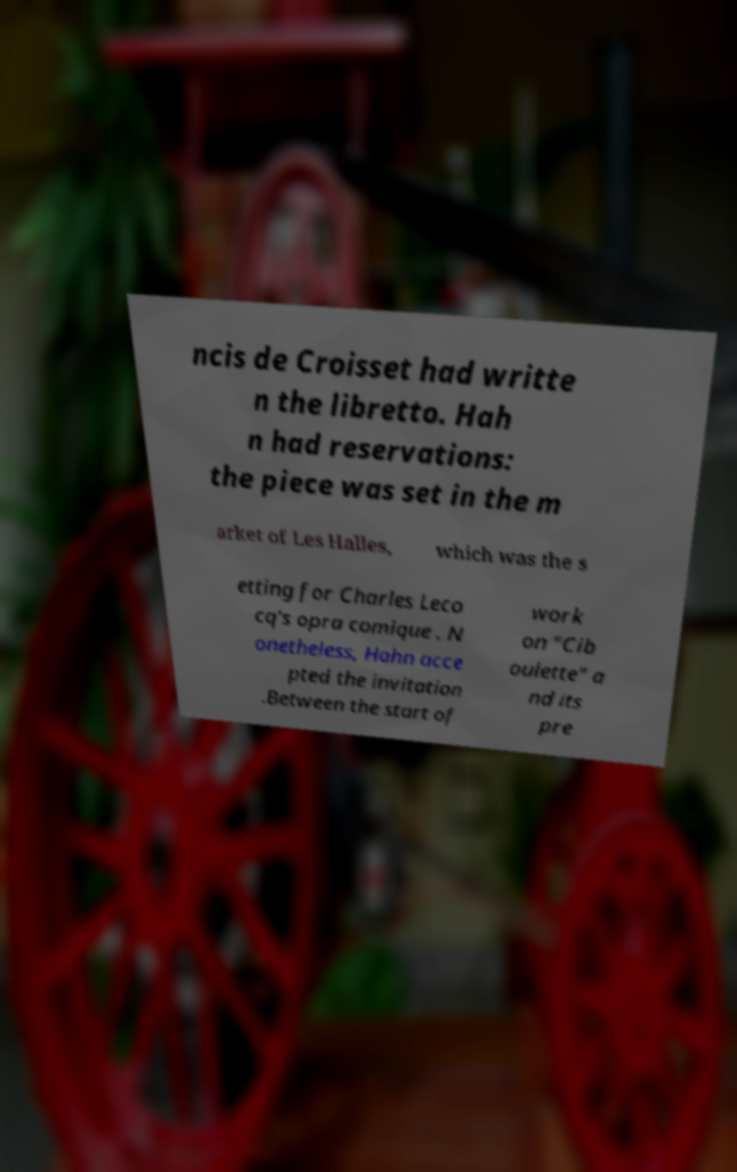Can you accurately transcribe the text from the provided image for me? ncis de Croisset had writte n the libretto. Hah n had reservations: the piece was set in the m arket of Les Halles, which was the s etting for Charles Leco cq's opra comique . N onetheless, Hahn acce pted the invitation .Between the start of work on "Cib oulette" a nd its pre 